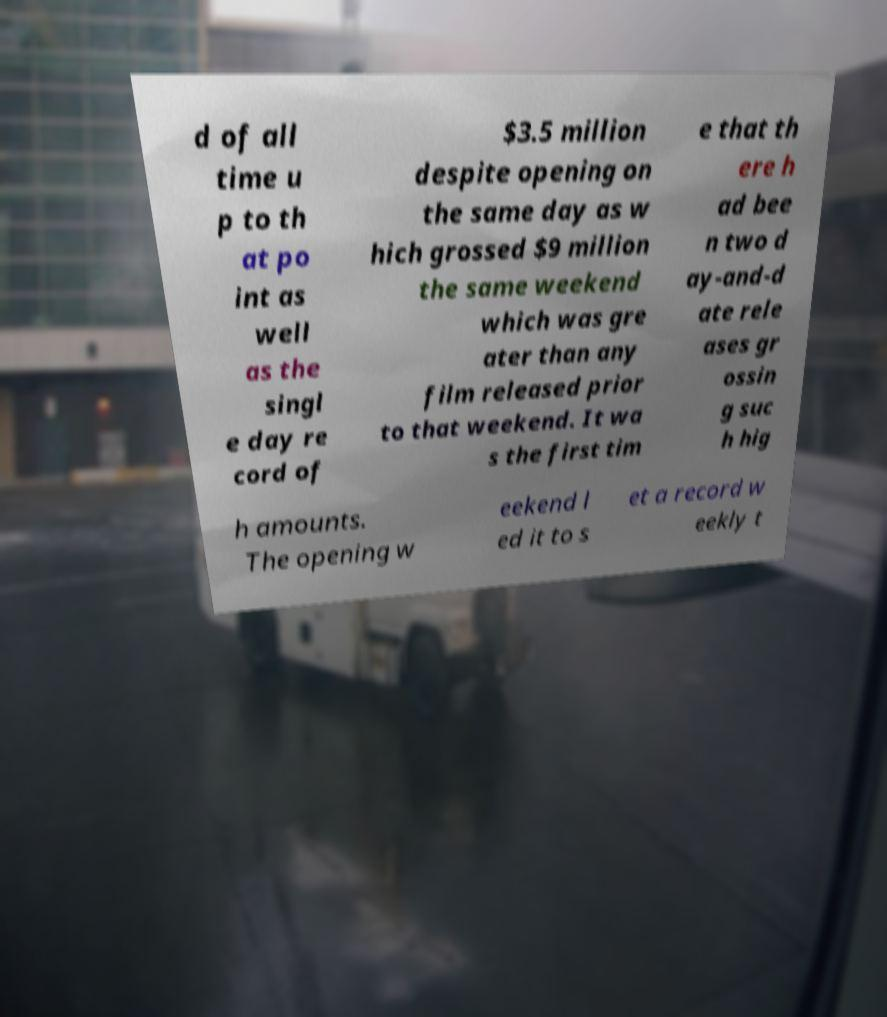Could you extract and type out the text from this image? d of all time u p to th at po int as well as the singl e day re cord of $3.5 million despite opening on the same day as w hich grossed $9 million the same weekend which was gre ater than any film released prior to that weekend. It wa s the first tim e that th ere h ad bee n two d ay-and-d ate rele ases gr ossin g suc h hig h amounts. The opening w eekend l ed it to s et a record w eekly t 